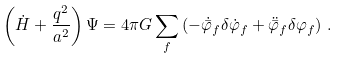<formula> <loc_0><loc_0><loc_500><loc_500>\left ( \dot { H } + \frac { q ^ { 2 } } { a ^ { 2 } } \right ) \Psi = 4 \pi G \sum _ { f } \left ( - \dot { \bar { \varphi } } _ { f } \delta \dot { \varphi } _ { f } + \ddot { \bar { \varphi } } _ { f } \delta \varphi _ { f } \right ) \, .</formula> 